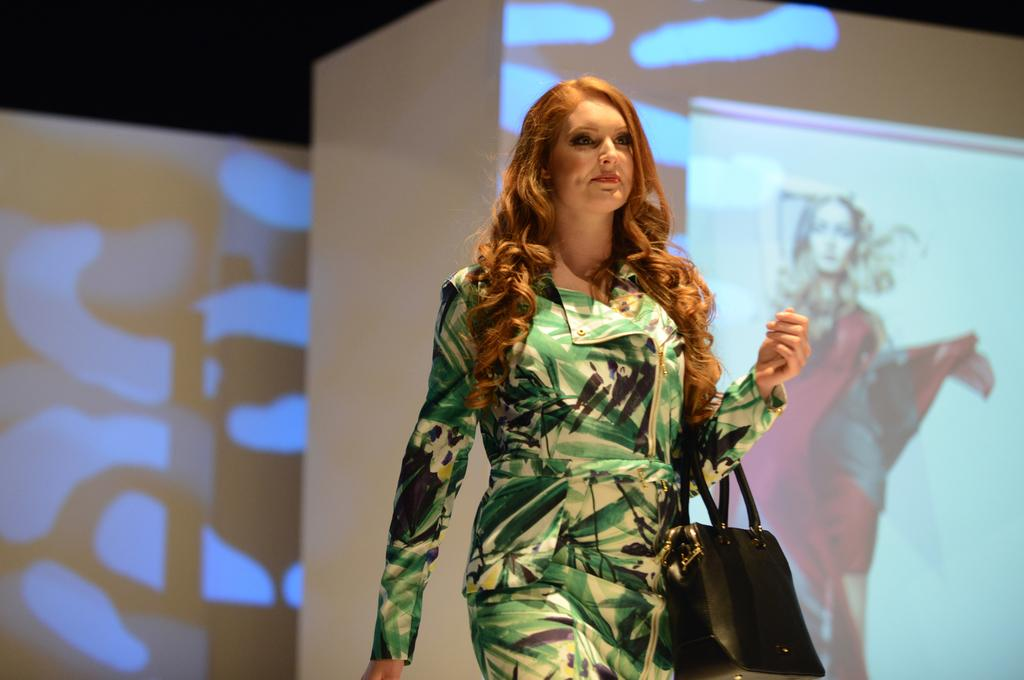Who is the main subject in the image? There is a woman in the image. What is the woman carrying in the image? The woman is carrying a handbag. What can be seen in the background of the image? There is a wall and a screen in the background of the image. What acting role does the woman play in the image? There is no indication in the image that the woman is an actor or playing a role. 